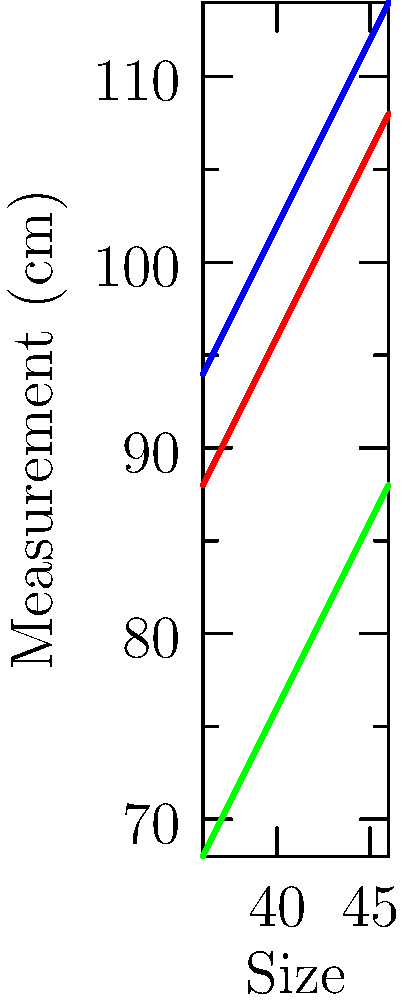Using the body measurement chart provided, calculate the grading increment for the bust measurement between sizes 40 and 44. How would you use this information to create a size-inclusive pattern that accommodates a wider range of body types? To solve this problem and create a size-inclusive pattern, follow these steps:

1. Identify the bust measurements for sizes 40 and 44:
   Size 40 bust: 96 cm
   Size 44 bust: 104 cm

2. Calculate the total difference:
   $104 \text{ cm} - 96 \text{ cm} = 8 \text{ cm}$

3. Determine the number of size intervals between 40 and 44:
   44 - 40 = 4 size intervals

4. Calculate the grading increment:
   $\text{Grading increment} = \frac{\text{Total difference}}{\text{Number of intervals}} = \frac{8 \text{ cm}}{4} = 2 \text{ cm}$

5. To create a size-inclusive pattern:
   a) Use the 2 cm increment as a base for grading between standard sizes.
   b) Consider adding intermediate sizes (e.g., 41, 43) to provide more options.
   c) Extend the size range beyond the chart (e.g., sizes 34, 48) using the same grading principle.
   d) Incorporate adjustable design elements like drawstrings or elastic panels.
   e) Use stretchy fabrics to accommodate variations within each size.
   f) Create a fit guide that helps customers choose the best size based on their measurements.

By implementing these strategies, you can create patterns that accommodate a wider range of body types and promote inclusivity in your gender-neutral clothing line.
Answer: 2 cm grading increment; extend size range, add intermediate sizes, use adjustable elements and stretchy fabrics 